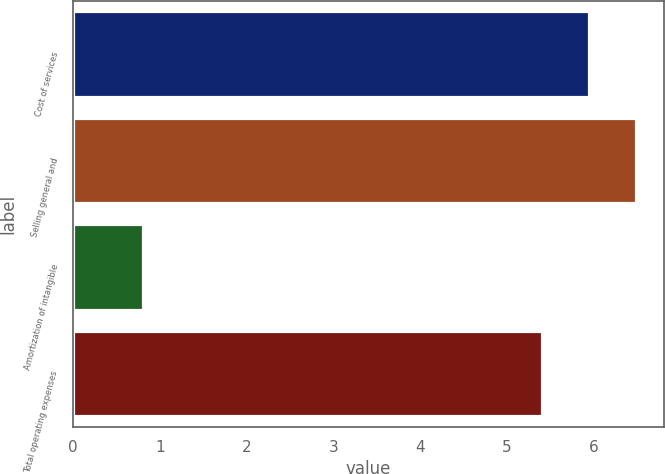Convert chart to OTSL. <chart><loc_0><loc_0><loc_500><loc_500><bar_chart><fcel>Cost of services<fcel>Selling general and<fcel>Amortization of intangible<fcel>Total operating expenses<nl><fcel>5.94<fcel>6.48<fcel>0.8<fcel>5.4<nl></chart> 